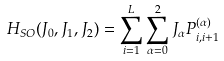<formula> <loc_0><loc_0><loc_500><loc_500>H _ { S O } ( J _ { 0 } , J _ { 1 } , J _ { 2 } ) = \sum _ { i = 1 } ^ { L } \sum _ { \alpha = 0 } ^ { 2 } J _ { \alpha } P ^ { ( \alpha ) } _ { i , i + 1 }</formula> 